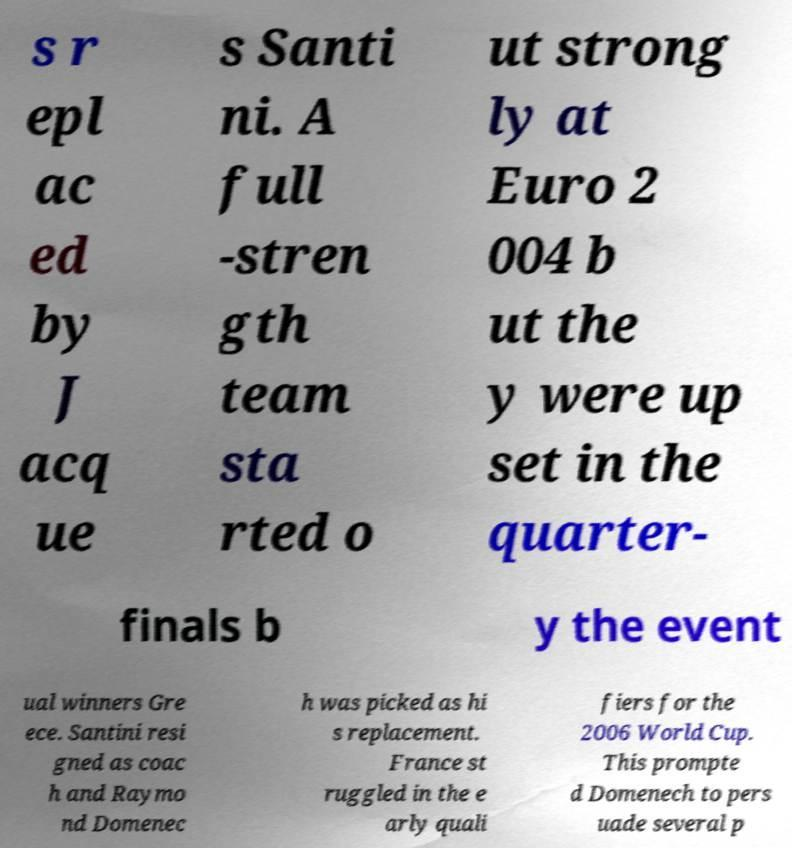I need the written content from this picture converted into text. Can you do that? s r epl ac ed by J acq ue s Santi ni. A full -stren gth team sta rted o ut strong ly at Euro 2 004 b ut the y were up set in the quarter- finals b y the event ual winners Gre ece. Santini resi gned as coac h and Raymo nd Domenec h was picked as hi s replacement. France st ruggled in the e arly quali fiers for the 2006 World Cup. This prompte d Domenech to pers uade several p 